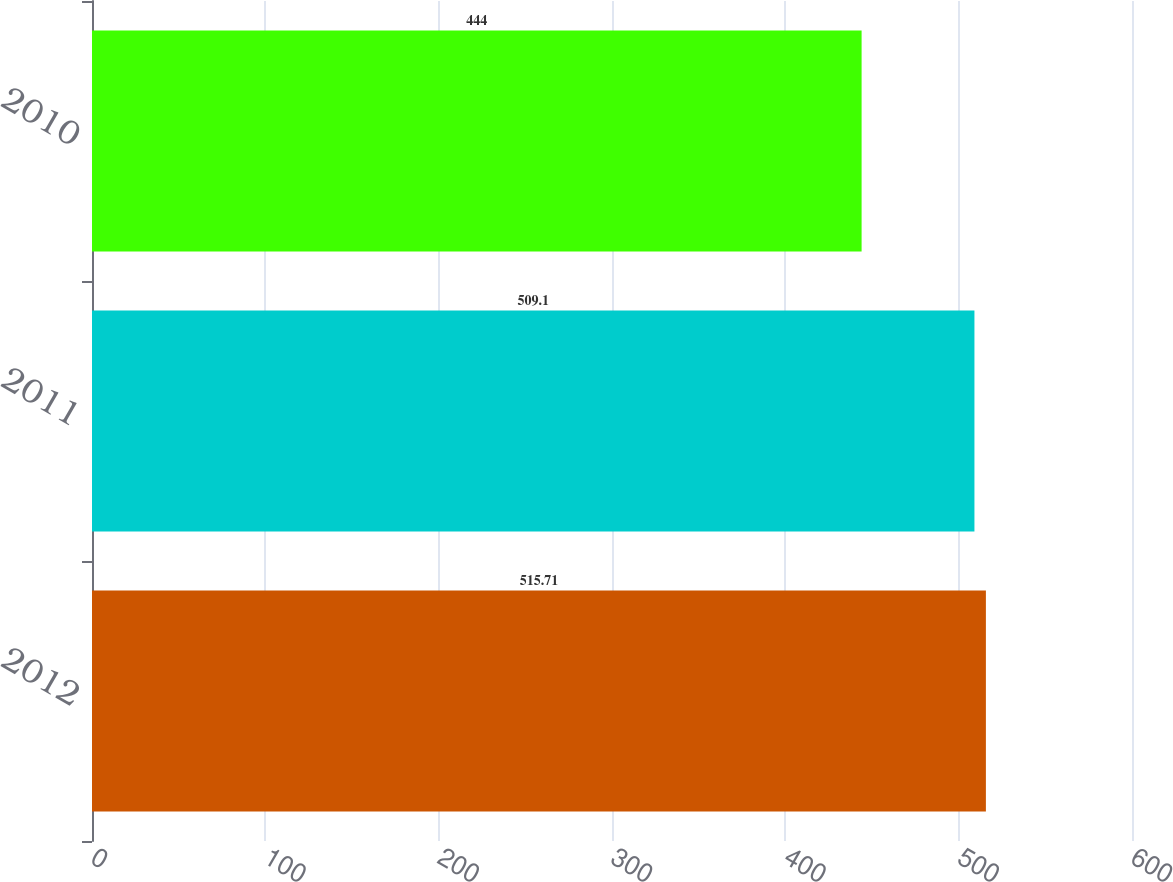Convert chart to OTSL. <chart><loc_0><loc_0><loc_500><loc_500><bar_chart><fcel>2012<fcel>2011<fcel>2010<nl><fcel>515.71<fcel>509.1<fcel>444<nl></chart> 